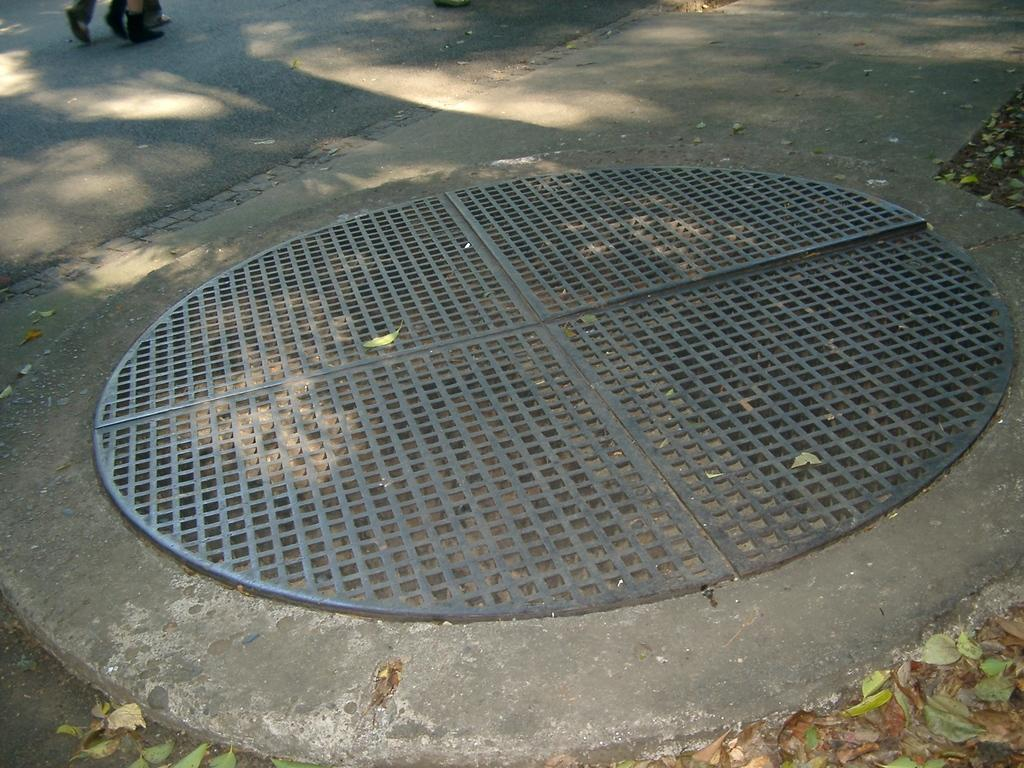What is the main feature of the image? There is a road in the image. Can you describe any other elements related to the road? A person's legs are visible on the road, and there is a manhole lid near the road. What else can be seen near the road? Leaves are present near the road. What type of suggestion is written on the shelf in the image? There is no shelf present in the image, so it is not possible to answer that question. 